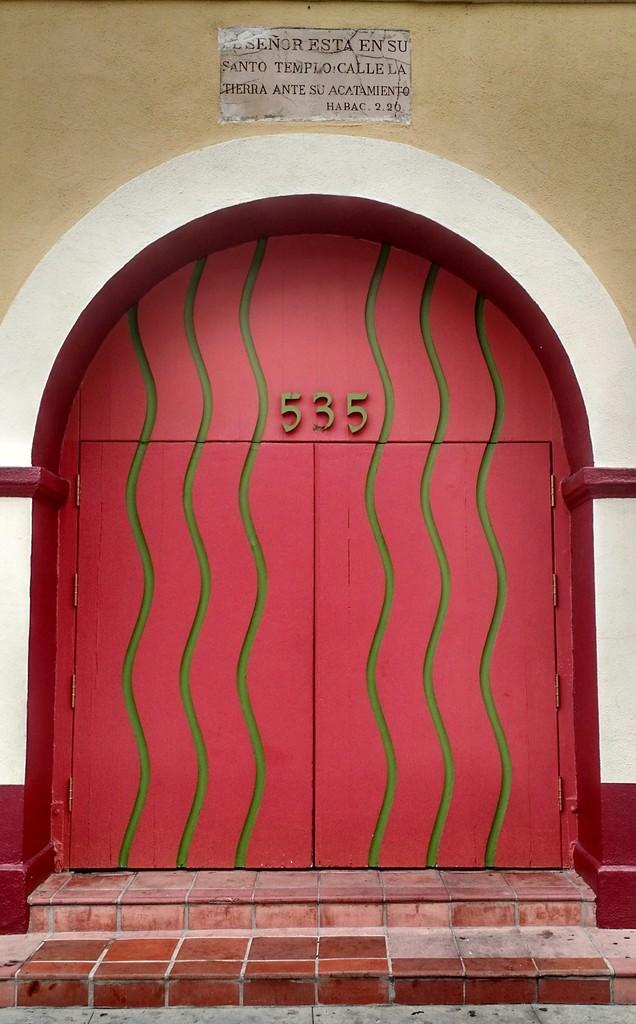Please provide a concise description of this image. In this image we can see a door with some numbers on it. We can also see a marble with some text on a wall and some stairs. 